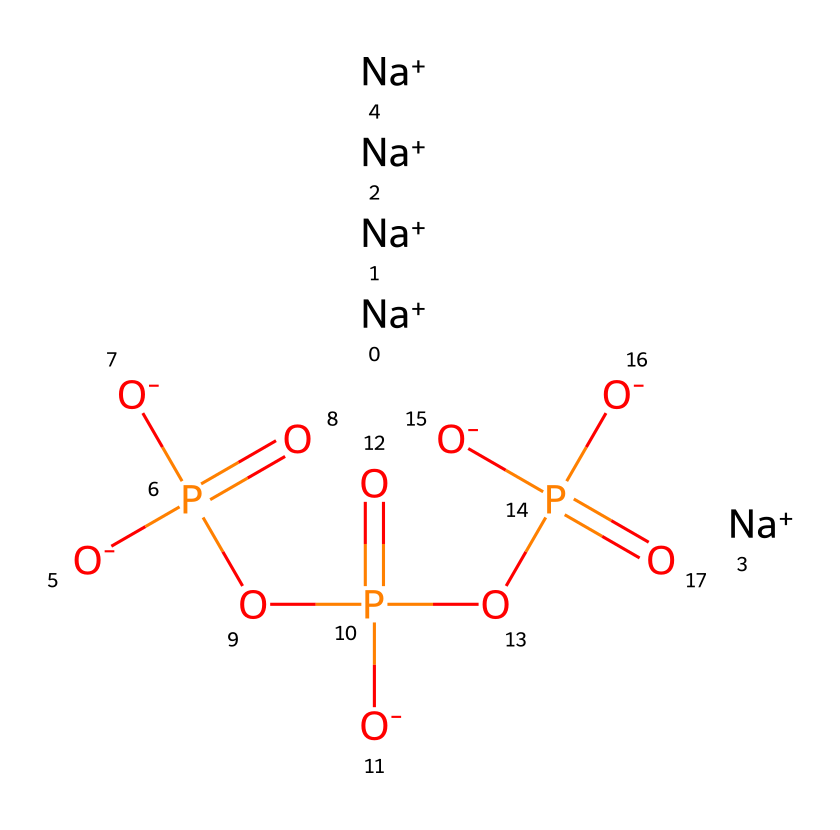What is the total number of sodium atoms in this compound? The SMILES notation shows six occurrences of "[Na+]", indicating there are six sodium atoms present in the chemical structure of sodium tripolyphosphate.
Answer: six How many phosphate groups are present in sodium tripolyphosphate? The structure has three phosphate groups, each represented by the "P" in the notation and surrounded by oxygen, confirming three distinct phosphate units in sodium tripolyphosphate.
Answer: three What is the overall charge of sodium tripolyphosphate? The notation has six sodium ions and four negative oxygen charges (from the various "[O-]"), leading to an overall charge of zero when the charges balance each other; thus, it is neutral.
Answer: neutral What type of bonds are primarily found in sodium tripolyphosphate? The structure includes strong covalent bonds between phosphorus and oxygen atoms, indicating that the primary bonds in this compound are covalent.
Answer: covalent What type of chemical is sodium tripolyphosphate? Sodium tripolyphosphate is classified as a salt, derived from the reaction of phosphoric acid with sodium hydroxide, which forms a compound composed of both sodium ions and polyphosphate anions.
Answer: salt How many oxygen atoms are present in sodium tripolyphosphate? Counting the oxygen atoms in the SMILES shows that there are thirteen oxygen atoms connected to the three phosphate groups and their shared nature, leading to a total of thirteen.
Answer: thirteen What feature of sodium tripolyphosphate allows it to act as a cleaning agent? The presence of multiple phosphate groups creates strong chelating properties, which help bind to metal ions in hard water, improving the effectiveness of detergents and cleaning products.
Answer: chelating properties 